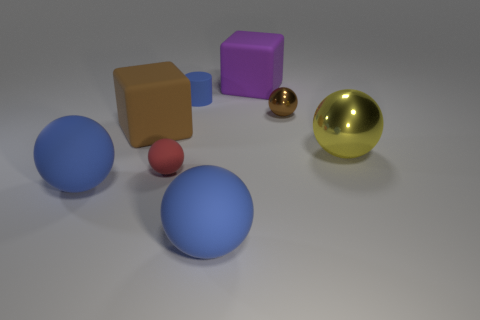Subtract all red spheres. How many spheres are left? 4 Subtract all small matte balls. How many balls are left? 4 Subtract all gray balls. Subtract all gray cylinders. How many balls are left? 5 Add 2 purple matte things. How many objects exist? 10 Subtract all cubes. How many objects are left? 6 Subtract all large blocks. Subtract all large brown matte blocks. How many objects are left? 5 Add 3 red matte objects. How many red matte objects are left? 4 Add 5 large cyan matte cylinders. How many large cyan matte cylinders exist? 5 Subtract 0 green balls. How many objects are left? 8 